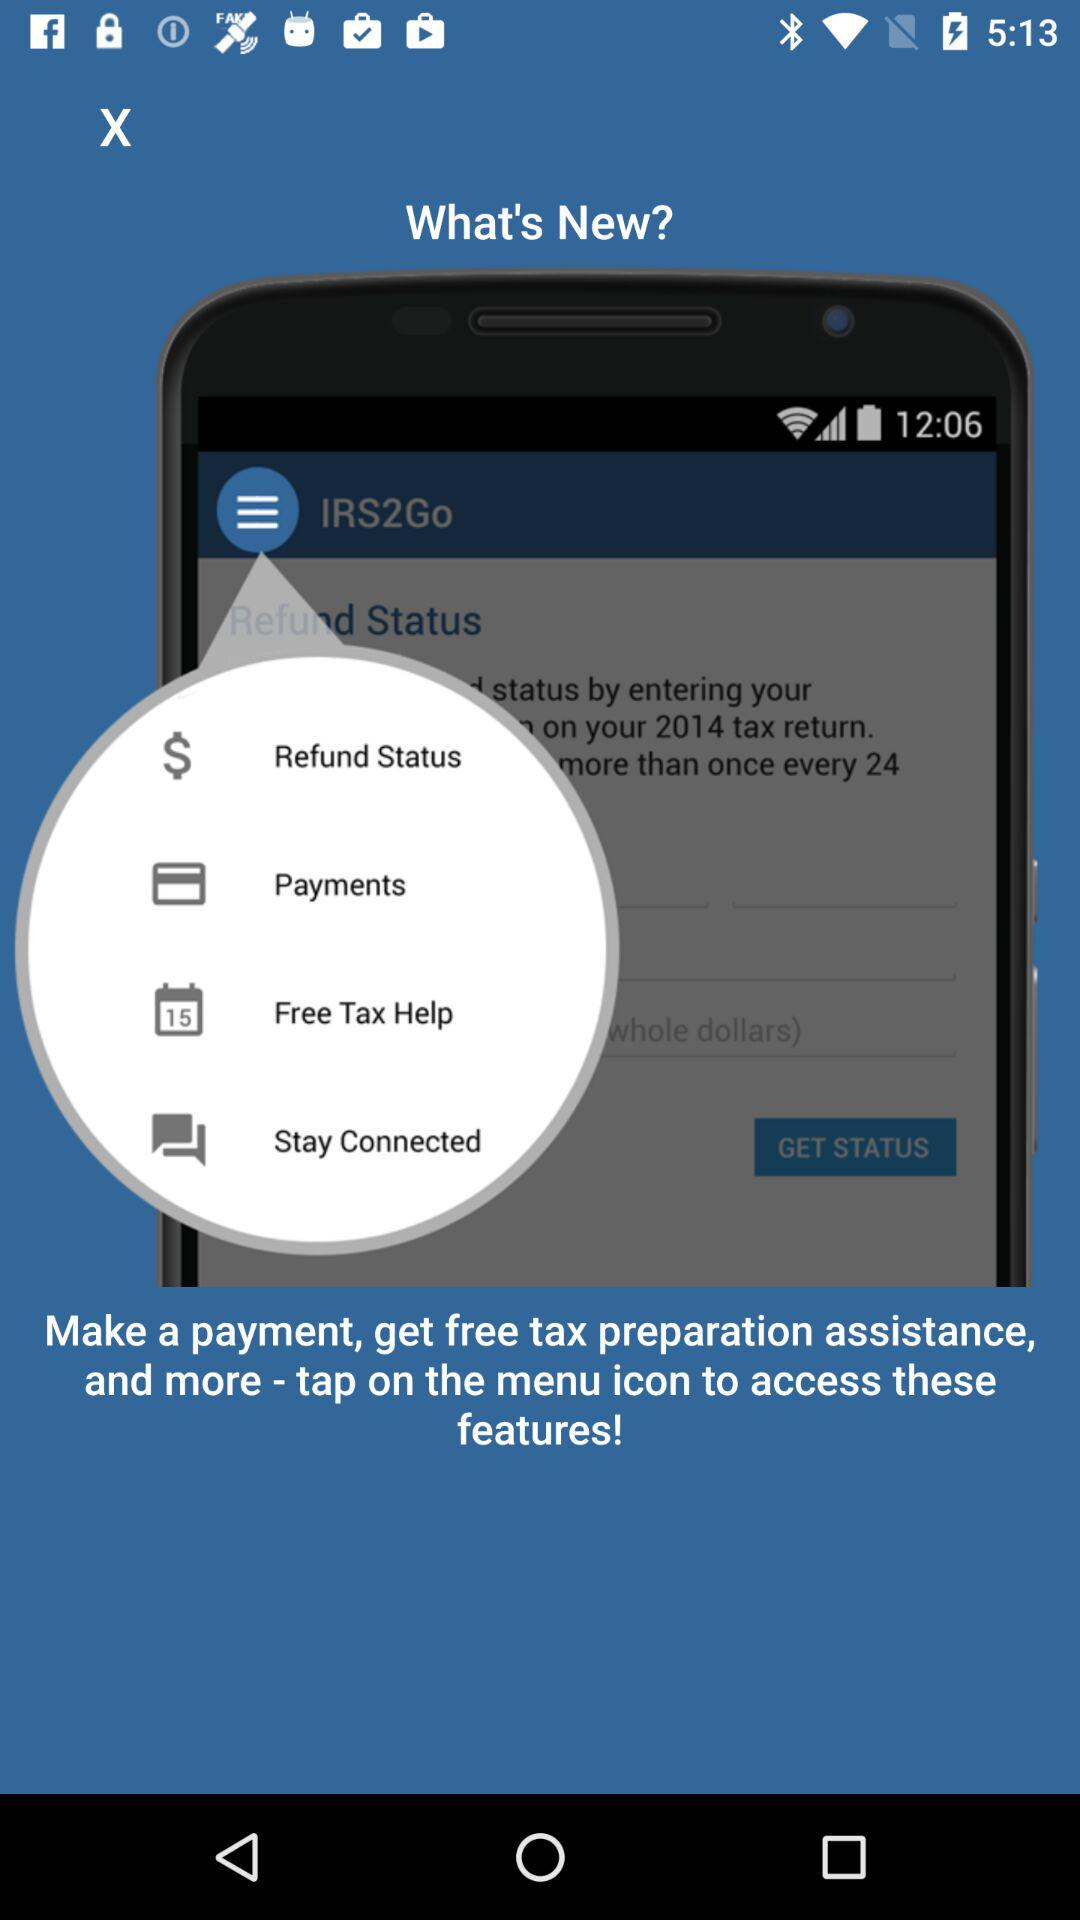How many menu items are there in the app?
Answer the question using a single word or phrase. 4 